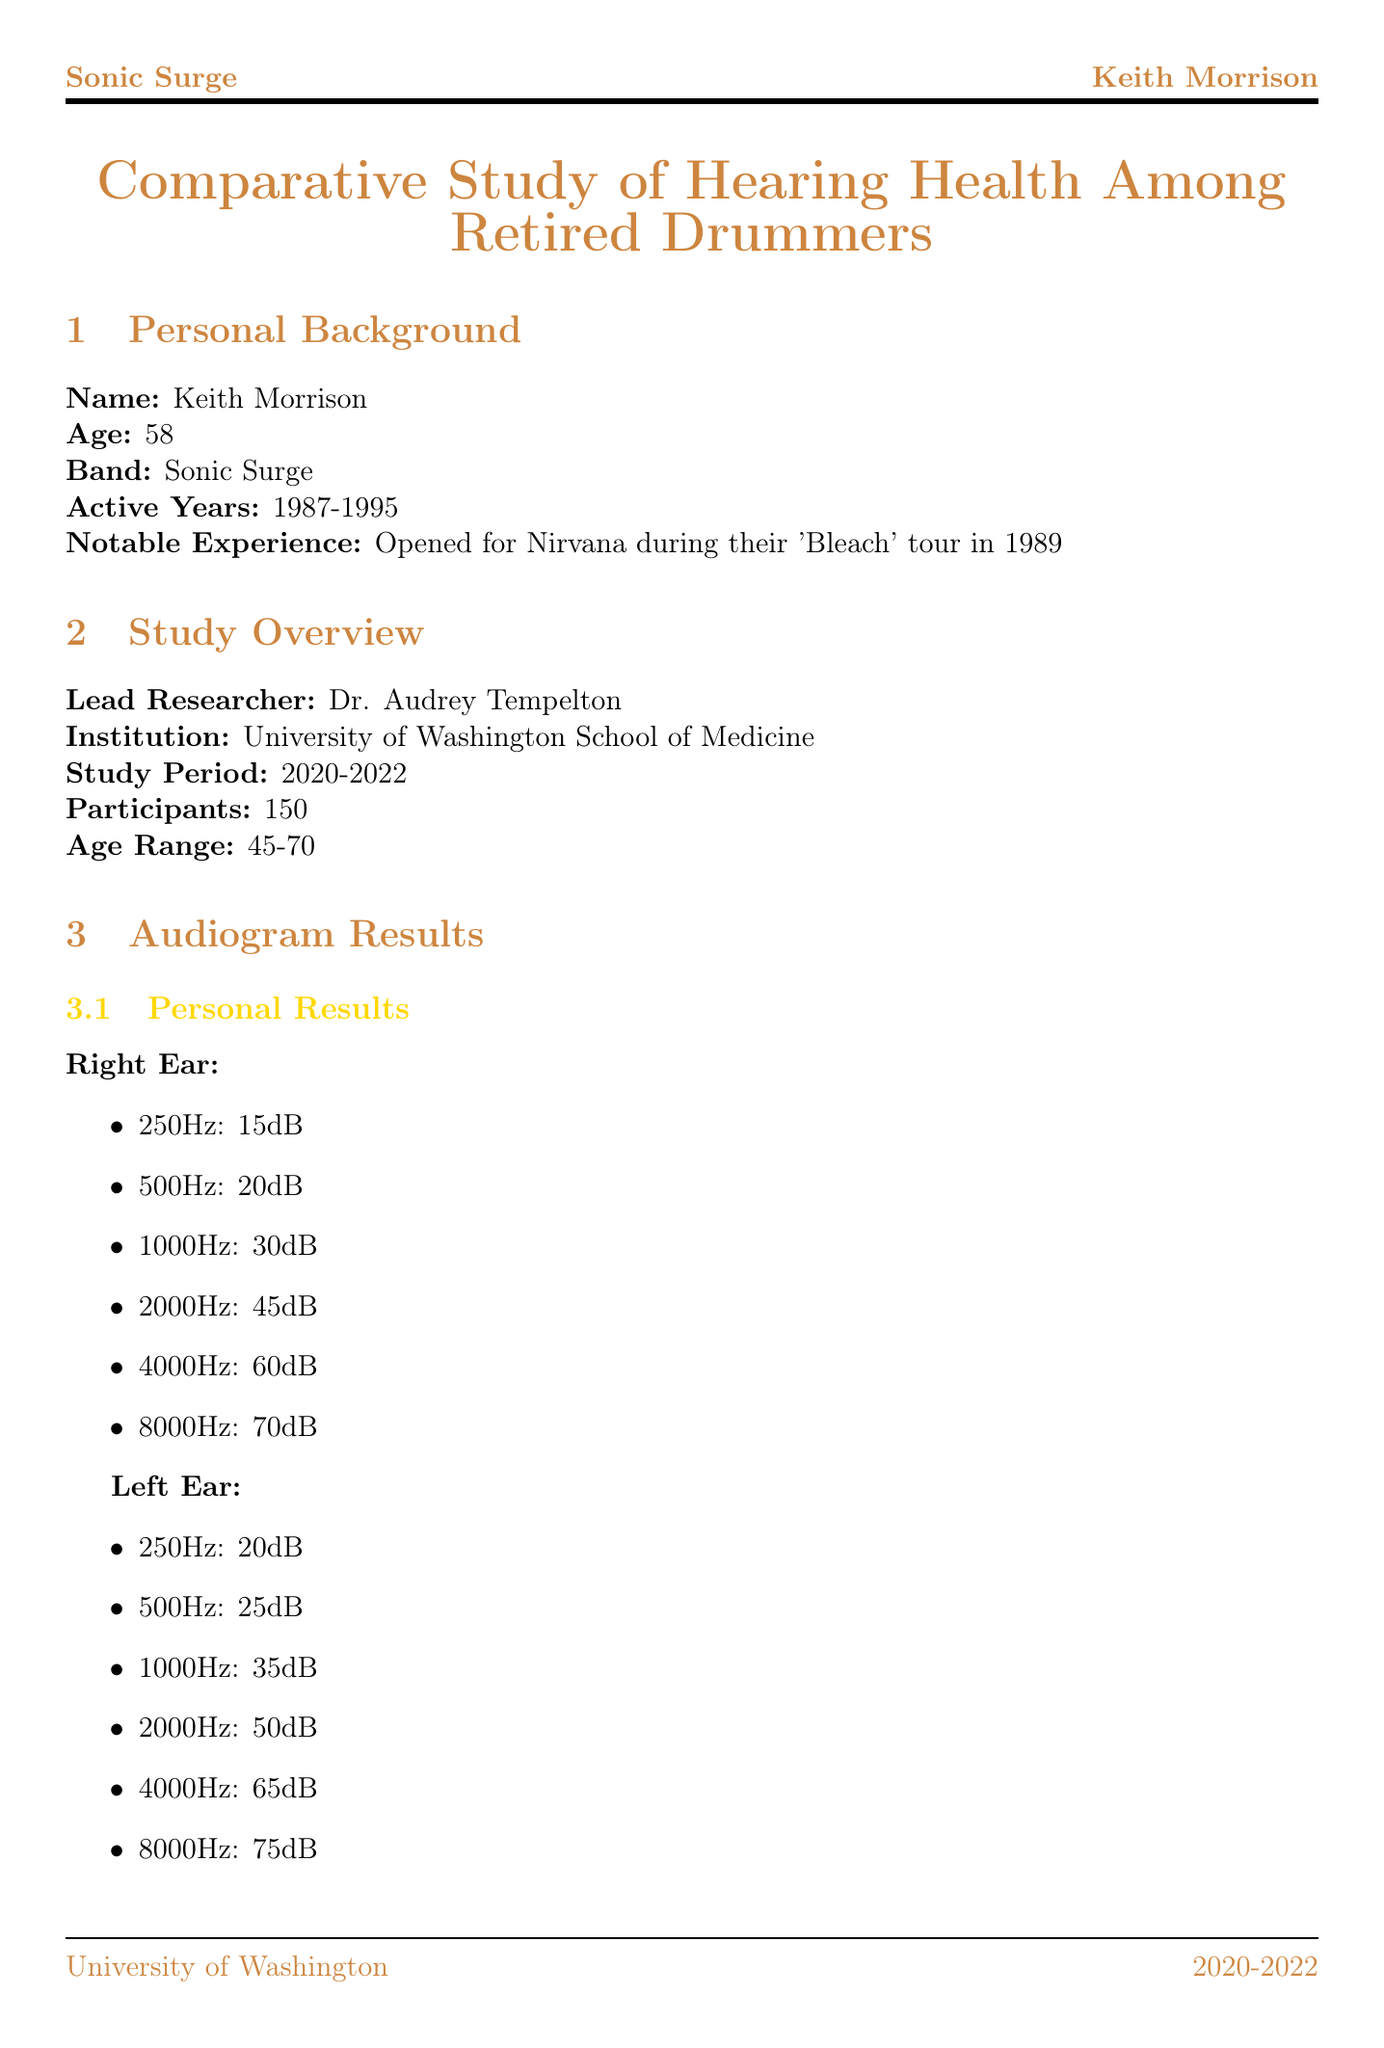What is the name of the lead researcher? The name of the lead researcher can be found in the study overview section.
Answer: Dr. Audrey Tempelton What is the age range of participants in the study? The age range is specified in the study overview section.
Answer: 45-70 What was the tinnitus handicap inventory score for Keith Morrison? This score is mentioned in the tinnitus assessment section under personal results.
Answer: 58 What percentage of participants reported tinnitus in the study? The prevalence of tinnitus is stated in the study statistics section.
Answer: 78% Which ear showed slightly worse hearing for most drummers? The comparative analysis section mentions this detail about hearing loss patterns.
Answer: Left ear What are two protective factors mentioned for drummers? Protective measures are listed in the comparative analysis section.
Answer: Custom-molded earplugs, Sound-dampening drum shields What is the name of the awareness campaign organized by the Hearing Health Foundation? The name of the awareness campaign is provided in the industry impact section.
Answer: Listen Smart What was Keith Morrison's notable experience as a musician? This information is detailed in the personal background section of the document.
Answer: Opened for Nirvana during their 'Bleach' tour in 1989 What is the severity level of Keith Morrison's tinnitus? The severity of tinnitus is described in the personal results of the tinnitus assessment section.
Answer: Moderate 